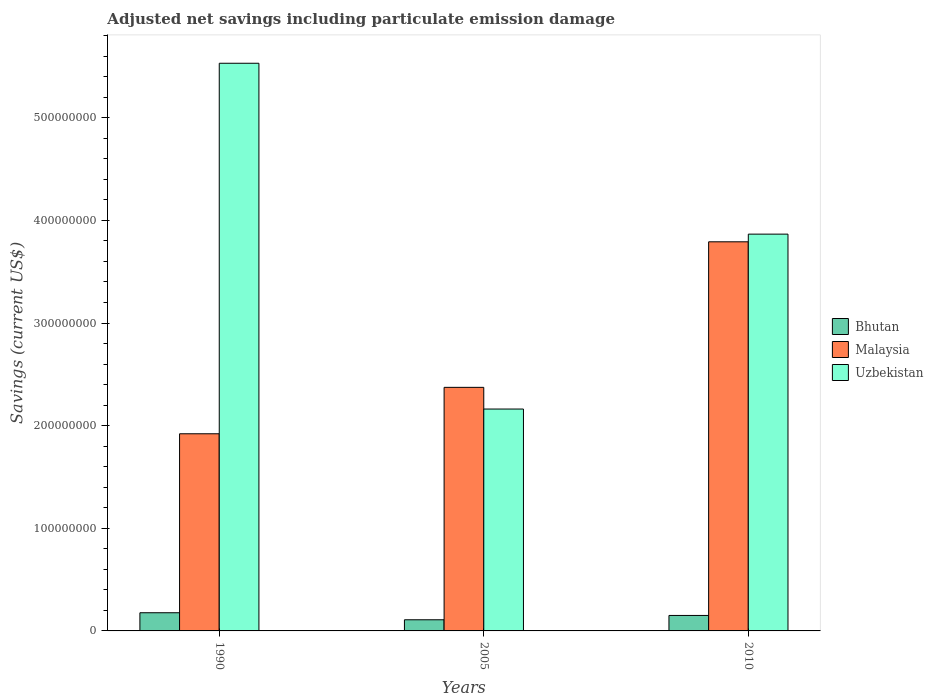How many groups of bars are there?
Provide a short and direct response. 3. Are the number of bars per tick equal to the number of legend labels?
Keep it short and to the point. Yes. How many bars are there on the 3rd tick from the left?
Ensure brevity in your answer.  3. In how many cases, is the number of bars for a given year not equal to the number of legend labels?
Provide a short and direct response. 0. What is the net savings in Malaysia in 2010?
Offer a terse response. 3.79e+08. Across all years, what is the maximum net savings in Uzbekistan?
Offer a very short reply. 5.53e+08. Across all years, what is the minimum net savings in Uzbekistan?
Offer a very short reply. 2.16e+08. In which year was the net savings in Bhutan maximum?
Give a very brief answer. 1990. In which year was the net savings in Uzbekistan minimum?
Provide a short and direct response. 2005. What is the total net savings in Malaysia in the graph?
Your answer should be compact. 8.09e+08. What is the difference between the net savings in Malaysia in 1990 and that in 2005?
Provide a short and direct response. -4.52e+07. What is the difference between the net savings in Uzbekistan in 2005 and the net savings in Malaysia in 1990?
Ensure brevity in your answer.  2.41e+07. What is the average net savings in Uzbekistan per year?
Ensure brevity in your answer.  3.85e+08. In the year 1990, what is the difference between the net savings in Bhutan and net savings in Malaysia?
Your answer should be very brief. -1.74e+08. What is the ratio of the net savings in Bhutan in 1990 to that in 2005?
Provide a succinct answer. 1.63. Is the net savings in Uzbekistan in 2005 less than that in 2010?
Provide a succinct answer. Yes. What is the difference between the highest and the second highest net savings in Malaysia?
Offer a very short reply. 1.42e+08. What is the difference between the highest and the lowest net savings in Bhutan?
Your response must be concise. 6.85e+06. In how many years, is the net savings in Uzbekistan greater than the average net savings in Uzbekistan taken over all years?
Give a very brief answer. 2. Is the sum of the net savings in Malaysia in 2005 and 2010 greater than the maximum net savings in Uzbekistan across all years?
Provide a succinct answer. Yes. What does the 1st bar from the left in 2010 represents?
Your response must be concise. Bhutan. What does the 1st bar from the right in 2005 represents?
Give a very brief answer. Uzbekistan. Is it the case that in every year, the sum of the net savings in Uzbekistan and net savings in Malaysia is greater than the net savings in Bhutan?
Your response must be concise. Yes. How many bars are there?
Ensure brevity in your answer.  9. How many years are there in the graph?
Provide a succinct answer. 3. What is the difference between two consecutive major ticks on the Y-axis?
Offer a terse response. 1.00e+08. Does the graph contain grids?
Keep it short and to the point. No. How are the legend labels stacked?
Offer a terse response. Vertical. What is the title of the graph?
Provide a succinct answer. Adjusted net savings including particulate emission damage. Does "American Samoa" appear as one of the legend labels in the graph?
Offer a terse response. No. What is the label or title of the Y-axis?
Make the answer very short. Savings (current US$). What is the Savings (current US$) of Bhutan in 1990?
Give a very brief answer. 1.77e+07. What is the Savings (current US$) of Malaysia in 1990?
Offer a terse response. 1.92e+08. What is the Savings (current US$) of Uzbekistan in 1990?
Make the answer very short. 5.53e+08. What is the Savings (current US$) in Bhutan in 2005?
Keep it short and to the point. 1.09e+07. What is the Savings (current US$) of Malaysia in 2005?
Your answer should be very brief. 2.37e+08. What is the Savings (current US$) in Uzbekistan in 2005?
Your answer should be compact. 2.16e+08. What is the Savings (current US$) in Bhutan in 2010?
Your answer should be compact. 1.51e+07. What is the Savings (current US$) in Malaysia in 2010?
Give a very brief answer. 3.79e+08. What is the Savings (current US$) of Uzbekistan in 2010?
Offer a very short reply. 3.87e+08. Across all years, what is the maximum Savings (current US$) in Bhutan?
Ensure brevity in your answer.  1.77e+07. Across all years, what is the maximum Savings (current US$) of Malaysia?
Give a very brief answer. 3.79e+08. Across all years, what is the maximum Savings (current US$) in Uzbekistan?
Offer a very short reply. 5.53e+08. Across all years, what is the minimum Savings (current US$) in Bhutan?
Provide a short and direct response. 1.09e+07. Across all years, what is the minimum Savings (current US$) in Malaysia?
Offer a terse response. 1.92e+08. Across all years, what is the minimum Savings (current US$) of Uzbekistan?
Keep it short and to the point. 2.16e+08. What is the total Savings (current US$) of Bhutan in the graph?
Provide a succinct answer. 4.36e+07. What is the total Savings (current US$) in Malaysia in the graph?
Make the answer very short. 8.09e+08. What is the total Savings (current US$) of Uzbekistan in the graph?
Your answer should be very brief. 1.16e+09. What is the difference between the Savings (current US$) of Bhutan in 1990 and that in 2005?
Your answer should be compact. 6.85e+06. What is the difference between the Savings (current US$) in Malaysia in 1990 and that in 2005?
Your response must be concise. -4.52e+07. What is the difference between the Savings (current US$) in Uzbekistan in 1990 and that in 2005?
Provide a succinct answer. 3.37e+08. What is the difference between the Savings (current US$) of Bhutan in 1990 and that in 2010?
Your response must be concise. 2.62e+06. What is the difference between the Savings (current US$) of Malaysia in 1990 and that in 2010?
Provide a short and direct response. -1.87e+08. What is the difference between the Savings (current US$) in Uzbekistan in 1990 and that in 2010?
Your answer should be compact. 1.66e+08. What is the difference between the Savings (current US$) in Bhutan in 2005 and that in 2010?
Offer a very short reply. -4.23e+06. What is the difference between the Savings (current US$) of Malaysia in 2005 and that in 2010?
Offer a very short reply. -1.42e+08. What is the difference between the Savings (current US$) in Uzbekistan in 2005 and that in 2010?
Your response must be concise. -1.70e+08. What is the difference between the Savings (current US$) in Bhutan in 1990 and the Savings (current US$) in Malaysia in 2005?
Provide a short and direct response. -2.20e+08. What is the difference between the Savings (current US$) in Bhutan in 1990 and the Savings (current US$) in Uzbekistan in 2005?
Your answer should be compact. -1.98e+08. What is the difference between the Savings (current US$) of Malaysia in 1990 and the Savings (current US$) of Uzbekistan in 2005?
Give a very brief answer. -2.41e+07. What is the difference between the Savings (current US$) in Bhutan in 1990 and the Savings (current US$) in Malaysia in 2010?
Your response must be concise. -3.61e+08. What is the difference between the Savings (current US$) of Bhutan in 1990 and the Savings (current US$) of Uzbekistan in 2010?
Your answer should be very brief. -3.69e+08. What is the difference between the Savings (current US$) of Malaysia in 1990 and the Savings (current US$) of Uzbekistan in 2010?
Your answer should be very brief. -1.95e+08. What is the difference between the Savings (current US$) in Bhutan in 2005 and the Savings (current US$) in Malaysia in 2010?
Make the answer very short. -3.68e+08. What is the difference between the Savings (current US$) in Bhutan in 2005 and the Savings (current US$) in Uzbekistan in 2010?
Give a very brief answer. -3.76e+08. What is the difference between the Savings (current US$) in Malaysia in 2005 and the Savings (current US$) in Uzbekistan in 2010?
Your answer should be very brief. -1.49e+08. What is the average Savings (current US$) of Bhutan per year?
Give a very brief answer. 1.45e+07. What is the average Savings (current US$) of Malaysia per year?
Give a very brief answer. 2.70e+08. What is the average Savings (current US$) of Uzbekistan per year?
Offer a very short reply. 3.85e+08. In the year 1990, what is the difference between the Savings (current US$) of Bhutan and Savings (current US$) of Malaysia?
Provide a succinct answer. -1.74e+08. In the year 1990, what is the difference between the Savings (current US$) in Bhutan and Savings (current US$) in Uzbekistan?
Make the answer very short. -5.35e+08. In the year 1990, what is the difference between the Savings (current US$) in Malaysia and Savings (current US$) in Uzbekistan?
Keep it short and to the point. -3.61e+08. In the year 2005, what is the difference between the Savings (current US$) of Bhutan and Savings (current US$) of Malaysia?
Ensure brevity in your answer.  -2.26e+08. In the year 2005, what is the difference between the Savings (current US$) of Bhutan and Savings (current US$) of Uzbekistan?
Ensure brevity in your answer.  -2.05e+08. In the year 2005, what is the difference between the Savings (current US$) in Malaysia and Savings (current US$) in Uzbekistan?
Give a very brief answer. 2.11e+07. In the year 2010, what is the difference between the Savings (current US$) of Bhutan and Savings (current US$) of Malaysia?
Provide a succinct answer. -3.64e+08. In the year 2010, what is the difference between the Savings (current US$) in Bhutan and Savings (current US$) in Uzbekistan?
Your answer should be compact. -3.72e+08. In the year 2010, what is the difference between the Savings (current US$) in Malaysia and Savings (current US$) in Uzbekistan?
Ensure brevity in your answer.  -7.47e+06. What is the ratio of the Savings (current US$) of Bhutan in 1990 to that in 2005?
Give a very brief answer. 1.63. What is the ratio of the Savings (current US$) of Malaysia in 1990 to that in 2005?
Your answer should be compact. 0.81. What is the ratio of the Savings (current US$) of Uzbekistan in 1990 to that in 2005?
Provide a short and direct response. 2.56. What is the ratio of the Savings (current US$) in Bhutan in 1990 to that in 2010?
Make the answer very short. 1.17. What is the ratio of the Savings (current US$) in Malaysia in 1990 to that in 2010?
Offer a very short reply. 0.51. What is the ratio of the Savings (current US$) of Uzbekistan in 1990 to that in 2010?
Make the answer very short. 1.43. What is the ratio of the Savings (current US$) of Bhutan in 2005 to that in 2010?
Your response must be concise. 0.72. What is the ratio of the Savings (current US$) in Malaysia in 2005 to that in 2010?
Provide a succinct answer. 0.63. What is the ratio of the Savings (current US$) in Uzbekistan in 2005 to that in 2010?
Ensure brevity in your answer.  0.56. What is the difference between the highest and the second highest Savings (current US$) of Bhutan?
Your answer should be compact. 2.62e+06. What is the difference between the highest and the second highest Savings (current US$) in Malaysia?
Offer a very short reply. 1.42e+08. What is the difference between the highest and the second highest Savings (current US$) in Uzbekistan?
Give a very brief answer. 1.66e+08. What is the difference between the highest and the lowest Savings (current US$) in Bhutan?
Keep it short and to the point. 6.85e+06. What is the difference between the highest and the lowest Savings (current US$) in Malaysia?
Keep it short and to the point. 1.87e+08. What is the difference between the highest and the lowest Savings (current US$) in Uzbekistan?
Provide a short and direct response. 3.37e+08. 